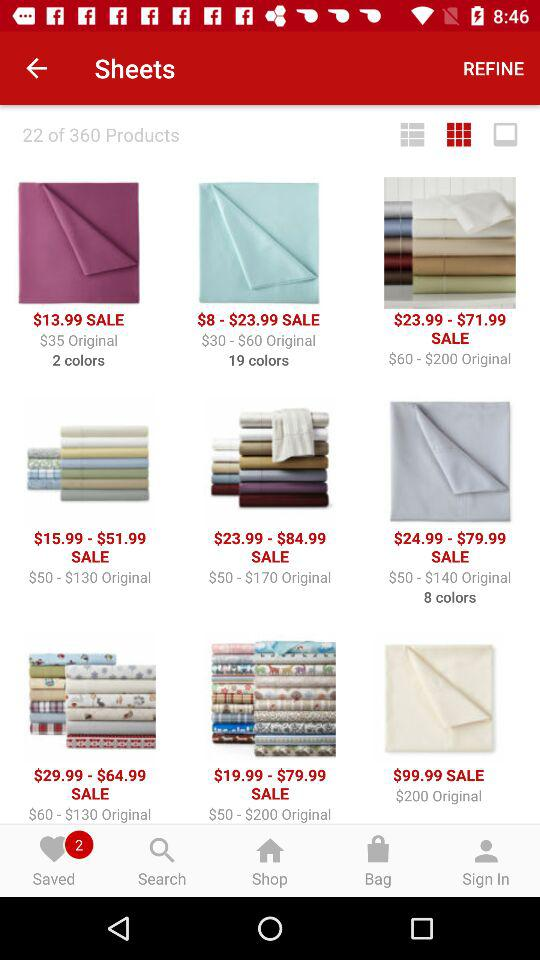How many items are there in "Saved"? There are 2 items in "Saved". 